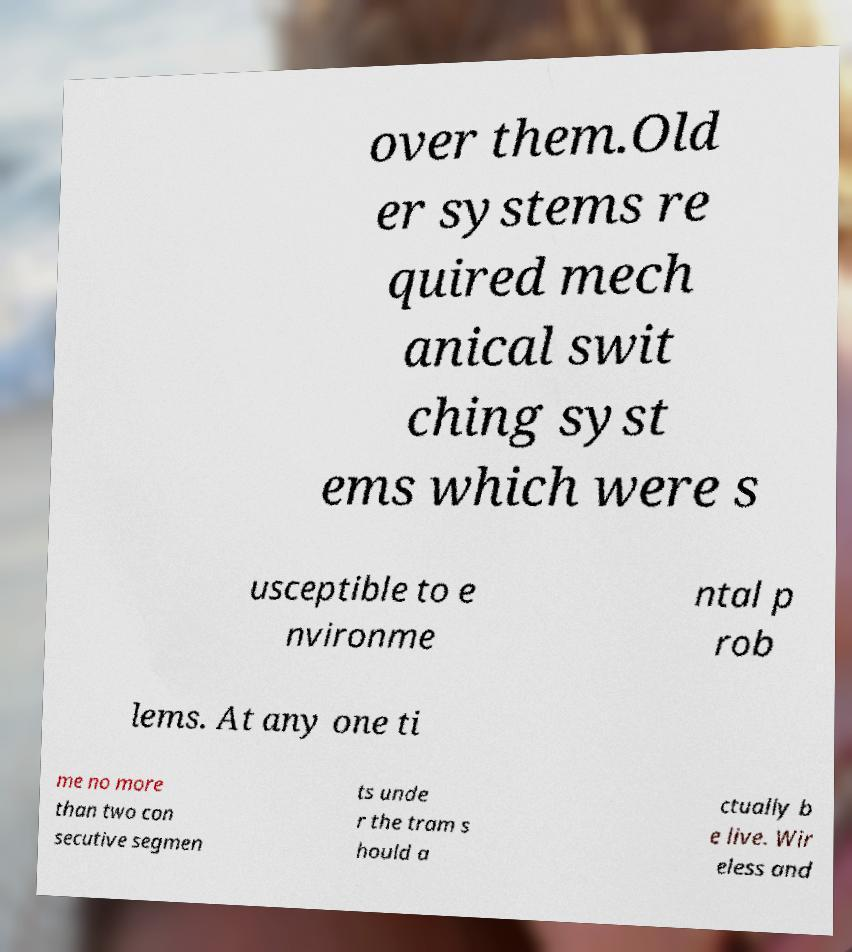Please identify and transcribe the text found in this image. over them.Old er systems re quired mech anical swit ching syst ems which were s usceptible to e nvironme ntal p rob lems. At any one ti me no more than two con secutive segmen ts unde r the tram s hould a ctually b e live. Wir eless and 